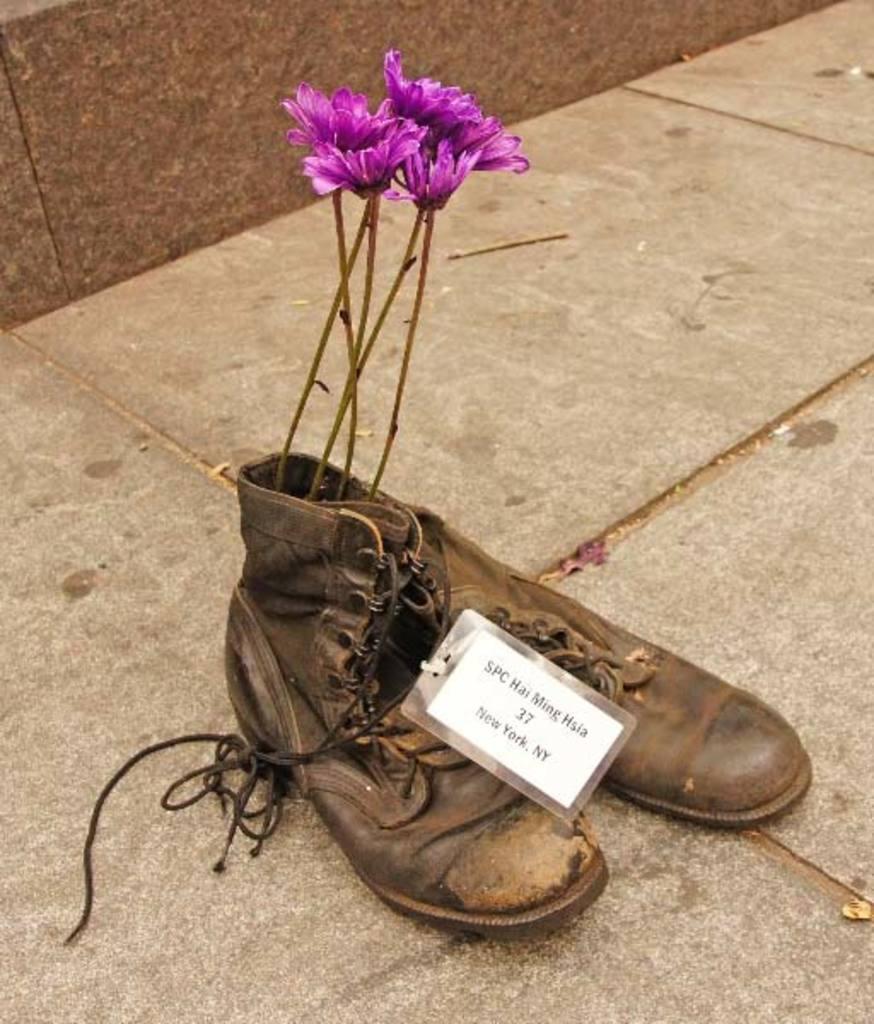How would you summarize this image in a sentence or two? This picture is clicked outside. In the center we can see the flowers placed in the shoe and the shoes are placed on the ground and there is a tag attached to the shoe on which the text is printed. In the background we can see the ground. 